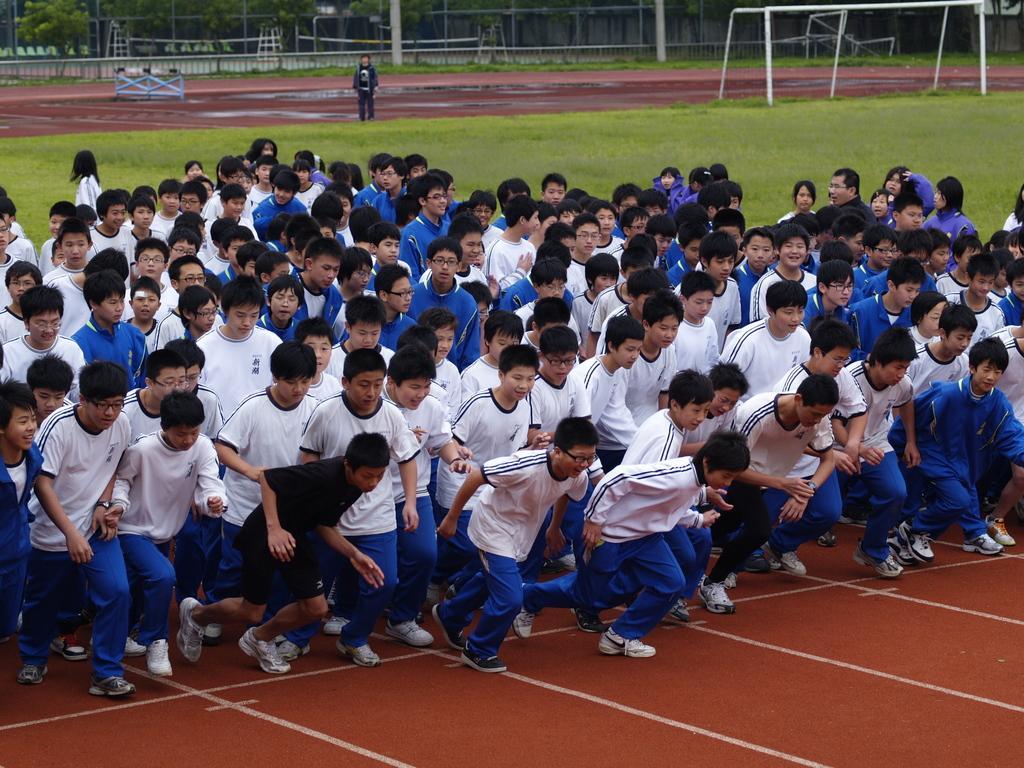Describe this image in one or two sentences. In the center of the image we can see people running. In the background there are rods, fence and trees. 